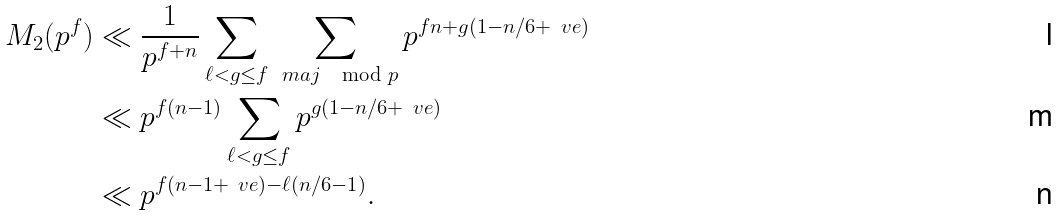<formula> <loc_0><loc_0><loc_500><loc_500>M _ { 2 } ( p ^ { f } ) & \ll \frac { 1 } { p ^ { f + n } } \sum _ { \ell < g \leq f } \sum _ { \ m a { j } \mod p } p ^ { f n + g ( 1 - n / 6 + \ v e ) } \\ & \ll p ^ { f ( n - 1 ) } \sum _ { \ell < g \leq f } p ^ { g ( 1 - n / 6 + \ v e ) } \\ & \ll p ^ { f ( n - 1 + \ v e ) - \ell ( n / 6 - 1 ) } .</formula> 